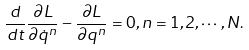Convert formula to latex. <formula><loc_0><loc_0><loc_500><loc_500>\frac { d } { d t } \frac { \partial L } { \partial \dot { q } ^ { n } } - \frac { \partial L } { \partial q ^ { n } } = 0 , n = 1 , 2 , \cdots , N .</formula> 